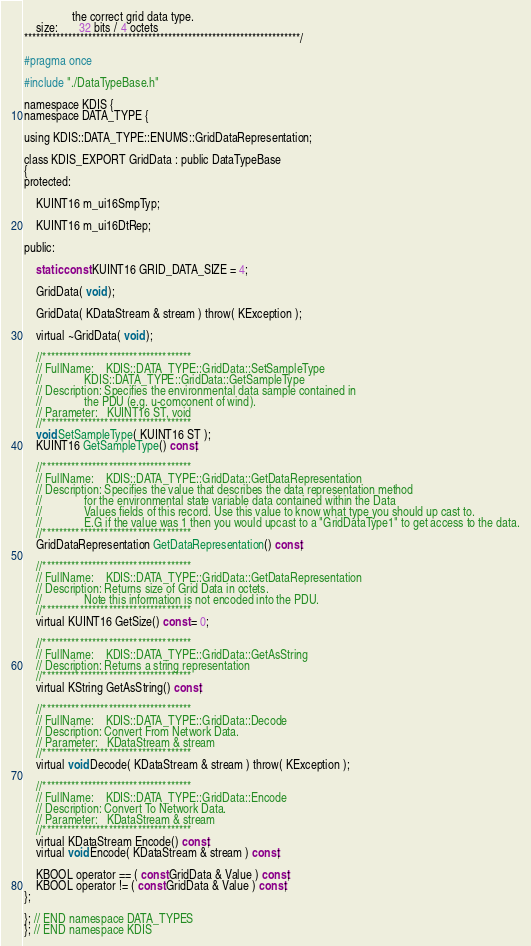Convert code to text. <code><loc_0><loc_0><loc_500><loc_500><_C_>                the correct grid data type.
    size:       32 bits / 4 octets
*********************************************************************/

#pragma once

#include "./DataTypeBase.h"

namespace KDIS {
namespace DATA_TYPE {

using KDIS::DATA_TYPE::ENUMS::GridDataRepresentation;

class KDIS_EXPORT GridData : public DataTypeBase
{
protected:

    KUINT16 m_ui16SmpTyp;

    KUINT16 m_ui16DtRep;

public:

    static const KUINT16 GRID_DATA_SIZE = 4;

    GridData( void );

    GridData( KDataStream & stream ) throw( KException );

    virtual ~GridData( void );

    //************************************
    // FullName:    KDIS::DATA_TYPE::GridData::SetSampleType
    //              KDIS::DATA_TYPE::GridData::GetSampleType
    // Description: Specifies the environmental data sample contained in
    //              the PDU (e.g. u-comconent of wind).
    // Parameter:   KUINT16 ST, void
    //************************************
    void SetSampleType( KUINT16 ST );
    KUINT16 GetSampleType() const;

    //************************************
    // FullName:    KDIS::DATA_TYPE::GridData::GetDataRepresentation
    // Description: Specifies the value that describes the data representation method
    //              for the environmental state variable data contained within the Data
    //              Values fields of this record. Use this value to know what type you should up cast to.
    //              E.G if the value was 1 then you would upcast to a "GridDataType1" to get access to the data.
    //************************************
    GridDataRepresentation GetDataRepresentation() const;

    //************************************
    // FullName:    KDIS::DATA_TYPE::GridData::GetDataRepresentation
    // Description: Returns size of Grid Data in octets.
    //              Note this information is not encoded into the PDU.
    //************************************
    virtual KUINT16 GetSize() const = 0;

    //************************************
    // FullName:    KDIS::DATA_TYPE::GridData::GetAsString
    // Description: Returns a string representation
    //************************************
    virtual KString GetAsString() const;

    //************************************
    // FullName:    KDIS::DATA_TYPE::GridData::Decode
    // Description: Convert From Network Data.
    // Parameter:   KDataStream & stream
    //************************************
    virtual void Decode( KDataStream & stream ) throw( KException );

    //************************************
    // FullName:    KDIS::DATA_TYPE::GridData::Encode
    // Description: Convert To Network Data.
    // Parameter:   KDataStream & stream
    //************************************
    virtual KDataStream Encode() const;
    virtual void Encode( KDataStream & stream ) const;

    KBOOL operator == ( const GridData & Value ) const;
    KBOOL operator != ( const GridData & Value ) const;
};

}; // END namespace DATA_TYPES
}; // END namespace KDIS

</code> 